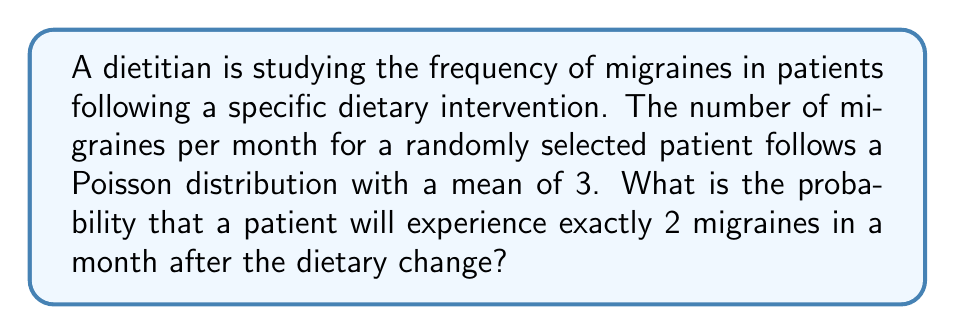Help me with this question. To solve this problem, we'll use the Poisson probability mass function:

$$P(X = k) = \frac{e^{-\lambda} \lambda^k}{k!}$$

Where:
$\lambda$ = mean number of events (migraines) per interval (month)
$k$ = number of events we're interested in
$e$ = Euler's number (approximately 2.71828)

Given:
$\lambda = 3$
$k = 2$

Step 1: Substitute the values into the formula:

$$P(X = 2) = \frac{e^{-3} 3^2}{2!}$$

Step 2: Simplify the numerator:
$$P(X = 2) = \frac{e^{-3} \cdot 9}{2}$$

Step 3: Calculate $e^{-3}$:
$$e^{-3} \approx 0.0497871$$

Step 4: Multiply the numerator:
$$P(X = 2) = \frac{0.0497871 \cdot 9}{2}$$

Step 5: Perform the final calculation:
$$P(X = 2) = \frac{0.4480839}{2} = 0.2240420$$

Therefore, the probability of a patient experiencing exactly 2 migraines in a month after the dietary change is approximately 0.2240 or 22.40%.
Answer: 0.2240 